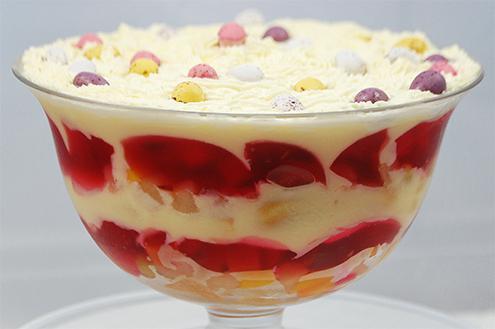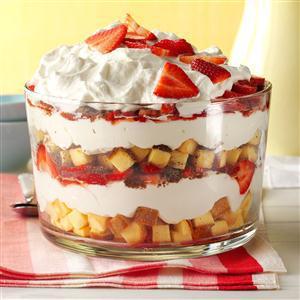The first image is the image on the left, the second image is the image on the right. Assess this claim about the two images: "At least one image shows a dessert garnished only with strawberry slices.". Correct or not? Answer yes or no. Yes. The first image is the image on the left, the second image is the image on the right. Evaluate the accuracy of this statement regarding the images: "The serving dish in the image on the right has a pedastal.". Is it true? Answer yes or no. No. 